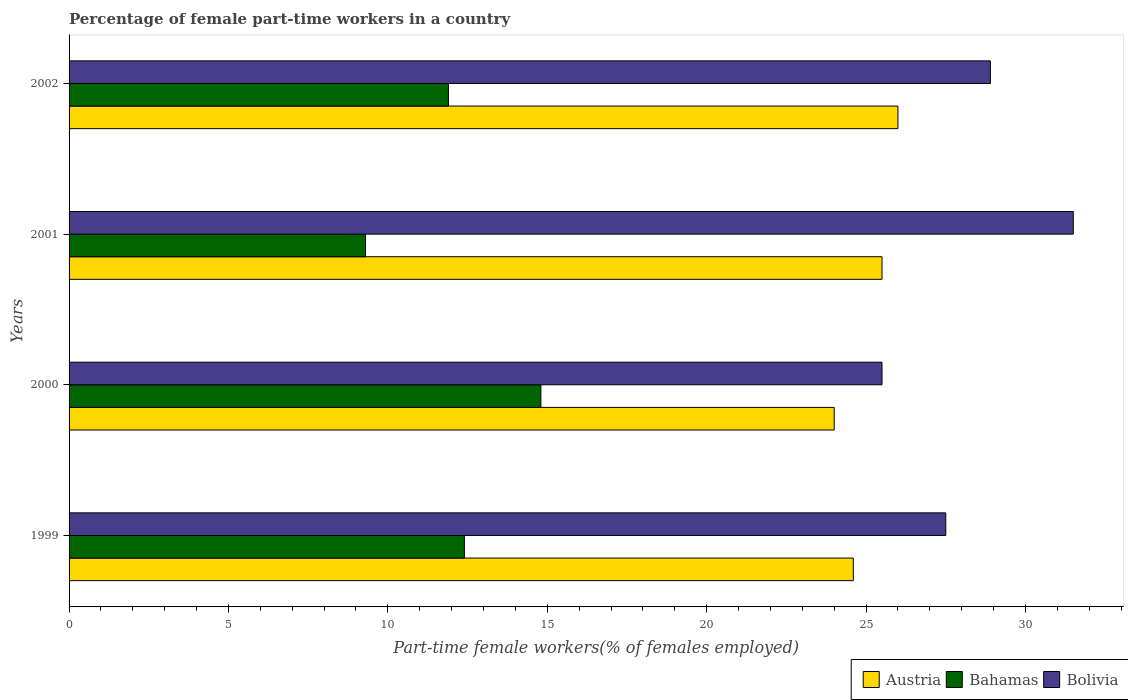Are the number of bars per tick equal to the number of legend labels?
Provide a succinct answer. Yes. Are the number of bars on each tick of the Y-axis equal?
Make the answer very short. Yes. How many bars are there on the 3rd tick from the top?
Make the answer very short. 3. What is the percentage of female part-time workers in Bolivia in 2002?
Offer a very short reply. 28.9. In which year was the percentage of female part-time workers in Bolivia maximum?
Offer a very short reply. 2001. In which year was the percentage of female part-time workers in Bahamas minimum?
Keep it short and to the point. 2001. What is the total percentage of female part-time workers in Bolivia in the graph?
Your response must be concise. 113.4. What is the difference between the percentage of female part-time workers in Bahamas in 1999 and that in 2001?
Offer a very short reply. 3.1. What is the difference between the percentage of female part-time workers in Austria in 2001 and the percentage of female part-time workers in Bolivia in 1999?
Provide a short and direct response. -2. What is the average percentage of female part-time workers in Austria per year?
Your answer should be very brief. 25.03. In the year 2002, what is the difference between the percentage of female part-time workers in Bahamas and percentage of female part-time workers in Austria?
Offer a terse response. -14.1. What is the ratio of the percentage of female part-time workers in Austria in 1999 to that in 2000?
Offer a terse response. 1.03. Is the difference between the percentage of female part-time workers in Bahamas in 2000 and 2002 greater than the difference between the percentage of female part-time workers in Austria in 2000 and 2002?
Your answer should be very brief. Yes. What is the difference between the highest and the second highest percentage of female part-time workers in Austria?
Offer a very short reply. 0.5. What is the difference between the highest and the lowest percentage of female part-time workers in Bolivia?
Give a very brief answer. 6. In how many years, is the percentage of female part-time workers in Bolivia greater than the average percentage of female part-time workers in Bolivia taken over all years?
Give a very brief answer. 2. What does the 2nd bar from the bottom in 2000 represents?
Your answer should be compact. Bahamas. Is it the case that in every year, the sum of the percentage of female part-time workers in Bolivia and percentage of female part-time workers in Bahamas is greater than the percentage of female part-time workers in Austria?
Offer a very short reply. Yes. Are all the bars in the graph horizontal?
Your response must be concise. Yes. How many years are there in the graph?
Offer a very short reply. 4. Are the values on the major ticks of X-axis written in scientific E-notation?
Give a very brief answer. No. Does the graph contain any zero values?
Offer a very short reply. No. How many legend labels are there?
Your answer should be very brief. 3. How are the legend labels stacked?
Your answer should be compact. Horizontal. What is the title of the graph?
Ensure brevity in your answer.  Percentage of female part-time workers in a country. Does "Tanzania" appear as one of the legend labels in the graph?
Your response must be concise. No. What is the label or title of the X-axis?
Give a very brief answer. Part-time female workers(% of females employed). What is the label or title of the Y-axis?
Make the answer very short. Years. What is the Part-time female workers(% of females employed) of Austria in 1999?
Keep it short and to the point. 24.6. What is the Part-time female workers(% of females employed) in Bahamas in 1999?
Ensure brevity in your answer.  12.4. What is the Part-time female workers(% of females employed) of Bolivia in 1999?
Make the answer very short. 27.5. What is the Part-time female workers(% of females employed) in Bahamas in 2000?
Ensure brevity in your answer.  14.8. What is the Part-time female workers(% of females employed) in Bolivia in 2000?
Make the answer very short. 25.5. What is the Part-time female workers(% of females employed) of Bahamas in 2001?
Give a very brief answer. 9.3. What is the Part-time female workers(% of females employed) of Bolivia in 2001?
Make the answer very short. 31.5. What is the Part-time female workers(% of females employed) in Bahamas in 2002?
Provide a succinct answer. 11.9. What is the Part-time female workers(% of females employed) of Bolivia in 2002?
Your answer should be very brief. 28.9. Across all years, what is the maximum Part-time female workers(% of females employed) in Austria?
Give a very brief answer. 26. Across all years, what is the maximum Part-time female workers(% of females employed) of Bahamas?
Keep it short and to the point. 14.8. Across all years, what is the maximum Part-time female workers(% of females employed) of Bolivia?
Keep it short and to the point. 31.5. Across all years, what is the minimum Part-time female workers(% of females employed) of Bahamas?
Give a very brief answer. 9.3. What is the total Part-time female workers(% of females employed) in Austria in the graph?
Make the answer very short. 100.1. What is the total Part-time female workers(% of females employed) in Bahamas in the graph?
Offer a terse response. 48.4. What is the total Part-time female workers(% of females employed) of Bolivia in the graph?
Offer a terse response. 113.4. What is the difference between the Part-time female workers(% of females employed) in Austria in 1999 and that in 2000?
Provide a succinct answer. 0.6. What is the difference between the Part-time female workers(% of females employed) of Austria in 1999 and that in 2001?
Keep it short and to the point. -0.9. What is the difference between the Part-time female workers(% of females employed) in Bahamas in 1999 and that in 2002?
Give a very brief answer. 0.5. What is the difference between the Part-time female workers(% of females employed) in Bolivia in 2000 and that in 2001?
Your response must be concise. -6. What is the difference between the Part-time female workers(% of females employed) in Bahamas in 2000 and that in 2002?
Give a very brief answer. 2.9. What is the difference between the Part-time female workers(% of females employed) in Bolivia in 2000 and that in 2002?
Ensure brevity in your answer.  -3.4. What is the difference between the Part-time female workers(% of females employed) of Austria in 2001 and that in 2002?
Ensure brevity in your answer.  -0.5. What is the difference between the Part-time female workers(% of females employed) in Bolivia in 2001 and that in 2002?
Make the answer very short. 2.6. What is the difference between the Part-time female workers(% of females employed) of Austria in 1999 and the Part-time female workers(% of females employed) of Bolivia in 2000?
Make the answer very short. -0.9. What is the difference between the Part-time female workers(% of females employed) of Bahamas in 1999 and the Part-time female workers(% of females employed) of Bolivia in 2000?
Give a very brief answer. -13.1. What is the difference between the Part-time female workers(% of females employed) of Austria in 1999 and the Part-time female workers(% of females employed) of Bahamas in 2001?
Provide a succinct answer. 15.3. What is the difference between the Part-time female workers(% of females employed) in Austria in 1999 and the Part-time female workers(% of females employed) in Bolivia in 2001?
Your answer should be very brief. -6.9. What is the difference between the Part-time female workers(% of females employed) in Bahamas in 1999 and the Part-time female workers(% of females employed) in Bolivia in 2001?
Make the answer very short. -19.1. What is the difference between the Part-time female workers(% of females employed) of Austria in 1999 and the Part-time female workers(% of females employed) of Bahamas in 2002?
Provide a short and direct response. 12.7. What is the difference between the Part-time female workers(% of females employed) in Austria in 1999 and the Part-time female workers(% of females employed) in Bolivia in 2002?
Your response must be concise. -4.3. What is the difference between the Part-time female workers(% of females employed) in Bahamas in 1999 and the Part-time female workers(% of females employed) in Bolivia in 2002?
Offer a very short reply. -16.5. What is the difference between the Part-time female workers(% of females employed) of Austria in 2000 and the Part-time female workers(% of females employed) of Bahamas in 2001?
Your response must be concise. 14.7. What is the difference between the Part-time female workers(% of females employed) in Bahamas in 2000 and the Part-time female workers(% of females employed) in Bolivia in 2001?
Your response must be concise. -16.7. What is the difference between the Part-time female workers(% of females employed) in Bahamas in 2000 and the Part-time female workers(% of females employed) in Bolivia in 2002?
Provide a succinct answer. -14.1. What is the difference between the Part-time female workers(% of females employed) in Bahamas in 2001 and the Part-time female workers(% of females employed) in Bolivia in 2002?
Make the answer very short. -19.6. What is the average Part-time female workers(% of females employed) of Austria per year?
Give a very brief answer. 25.02. What is the average Part-time female workers(% of females employed) of Bolivia per year?
Offer a terse response. 28.35. In the year 1999, what is the difference between the Part-time female workers(% of females employed) in Austria and Part-time female workers(% of females employed) in Bahamas?
Your response must be concise. 12.2. In the year 1999, what is the difference between the Part-time female workers(% of females employed) of Bahamas and Part-time female workers(% of females employed) of Bolivia?
Your response must be concise. -15.1. In the year 2000, what is the difference between the Part-time female workers(% of females employed) in Austria and Part-time female workers(% of females employed) in Bahamas?
Your answer should be very brief. 9.2. In the year 2000, what is the difference between the Part-time female workers(% of females employed) of Austria and Part-time female workers(% of females employed) of Bolivia?
Your answer should be compact. -1.5. In the year 2001, what is the difference between the Part-time female workers(% of females employed) in Austria and Part-time female workers(% of females employed) in Bahamas?
Your answer should be compact. 16.2. In the year 2001, what is the difference between the Part-time female workers(% of females employed) of Bahamas and Part-time female workers(% of females employed) of Bolivia?
Provide a succinct answer. -22.2. In the year 2002, what is the difference between the Part-time female workers(% of females employed) in Austria and Part-time female workers(% of females employed) in Bolivia?
Your response must be concise. -2.9. In the year 2002, what is the difference between the Part-time female workers(% of females employed) of Bahamas and Part-time female workers(% of females employed) of Bolivia?
Ensure brevity in your answer.  -17. What is the ratio of the Part-time female workers(% of females employed) in Bahamas in 1999 to that in 2000?
Offer a terse response. 0.84. What is the ratio of the Part-time female workers(% of females employed) of Bolivia in 1999 to that in 2000?
Provide a succinct answer. 1.08. What is the ratio of the Part-time female workers(% of females employed) of Austria in 1999 to that in 2001?
Ensure brevity in your answer.  0.96. What is the ratio of the Part-time female workers(% of females employed) of Bahamas in 1999 to that in 2001?
Provide a short and direct response. 1.33. What is the ratio of the Part-time female workers(% of females employed) of Bolivia in 1999 to that in 2001?
Offer a terse response. 0.87. What is the ratio of the Part-time female workers(% of females employed) in Austria in 1999 to that in 2002?
Ensure brevity in your answer.  0.95. What is the ratio of the Part-time female workers(% of females employed) of Bahamas in 1999 to that in 2002?
Make the answer very short. 1.04. What is the ratio of the Part-time female workers(% of females employed) in Bolivia in 1999 to that in 2002?
Provide a short and direct response. 0.95. What is the ratio of the Part-time female workers(% of females employed) in Bahamas in 2000 to that in 2001?
Ensure brevity in your answer.  1.59. What is the ratio of the Part-time female workers(% of females employed) of Bolivia in 2000 to that in 2001?
Provide a succinct answer. 0.81. What is the ratio of the Part-time female workers(% of females employed) in Bahamas in 2000 to that in 2002?
Your answer should be very brief. 1.24. What is the ratio of the Part-time female workers(% of females employed) of Bolivia in 2000 to that in 2002?
Offer a terse response. 0.88. What is the ratio of the Part-time female workers(% of females employed) of Austria in 2001 to that in 2002?
Offer a very short reply. 0.98. What is the ratio of the Part-time female workers(% of females employed) of Bahamas in 2001 to that in 2002?
Give a very brief answer. 0.78. What is the ratio of the Part-time female workers(% of females employed) in Bolivia in 2001 to that in 2002?
Your response must be concise. 1.09. What is the difference between the highest and the second highest Part-time female workers(% of females employed) of Bolivia?
Give a very brief answer. 2.6. What is the difference between the highest and the lowest Part-time female workers(% of females employed) in Bahamas?
Offer a terse response. 5.5. 